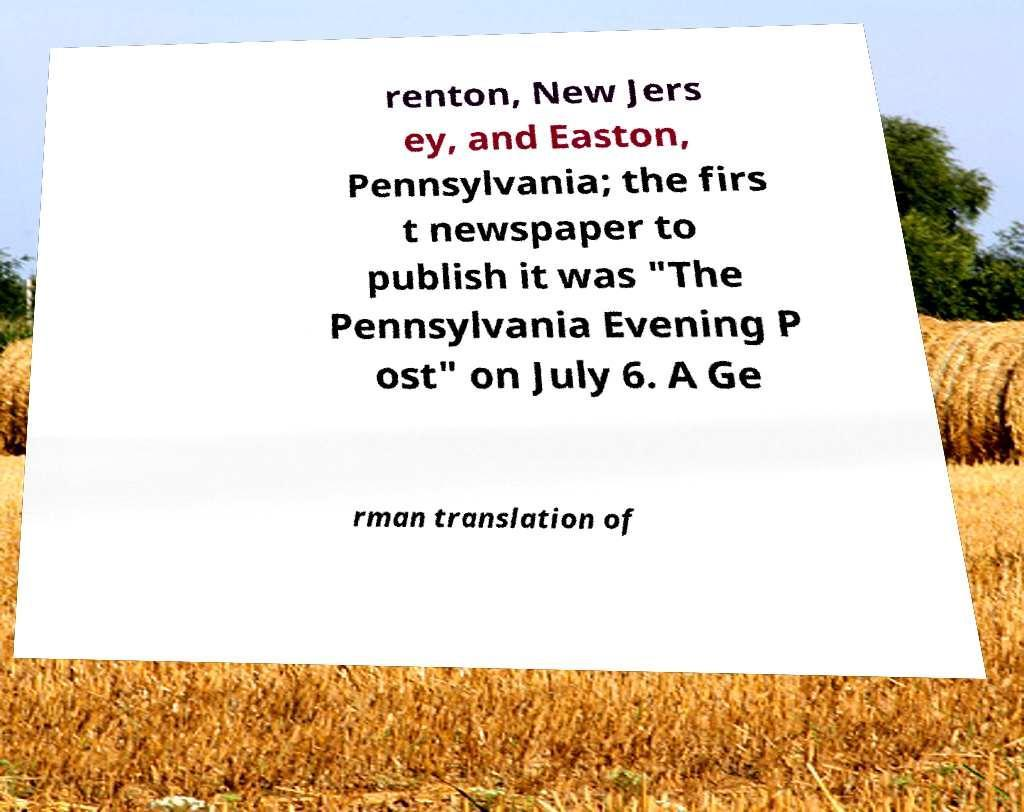Could you extract and type out the text from this image? renton, New Jers ey, and Easton, Pennsylvania; the firs t newspaper to publish it was "The Pennsylvania Evening P ost" on July 6. A Ge rman translation of 